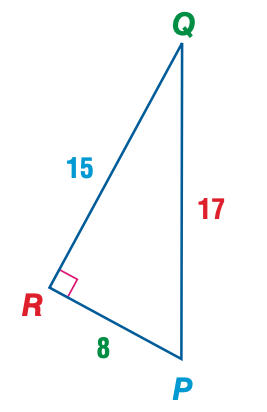Answer the mathemtical geometry problem and directly provide the correct option letter.
Question: Express the ratio of \cos Q as a decimal to the nearest hundredth.
Choices: A: 0.47 B: 0.53 C: 0.88 D: 1.88 C 